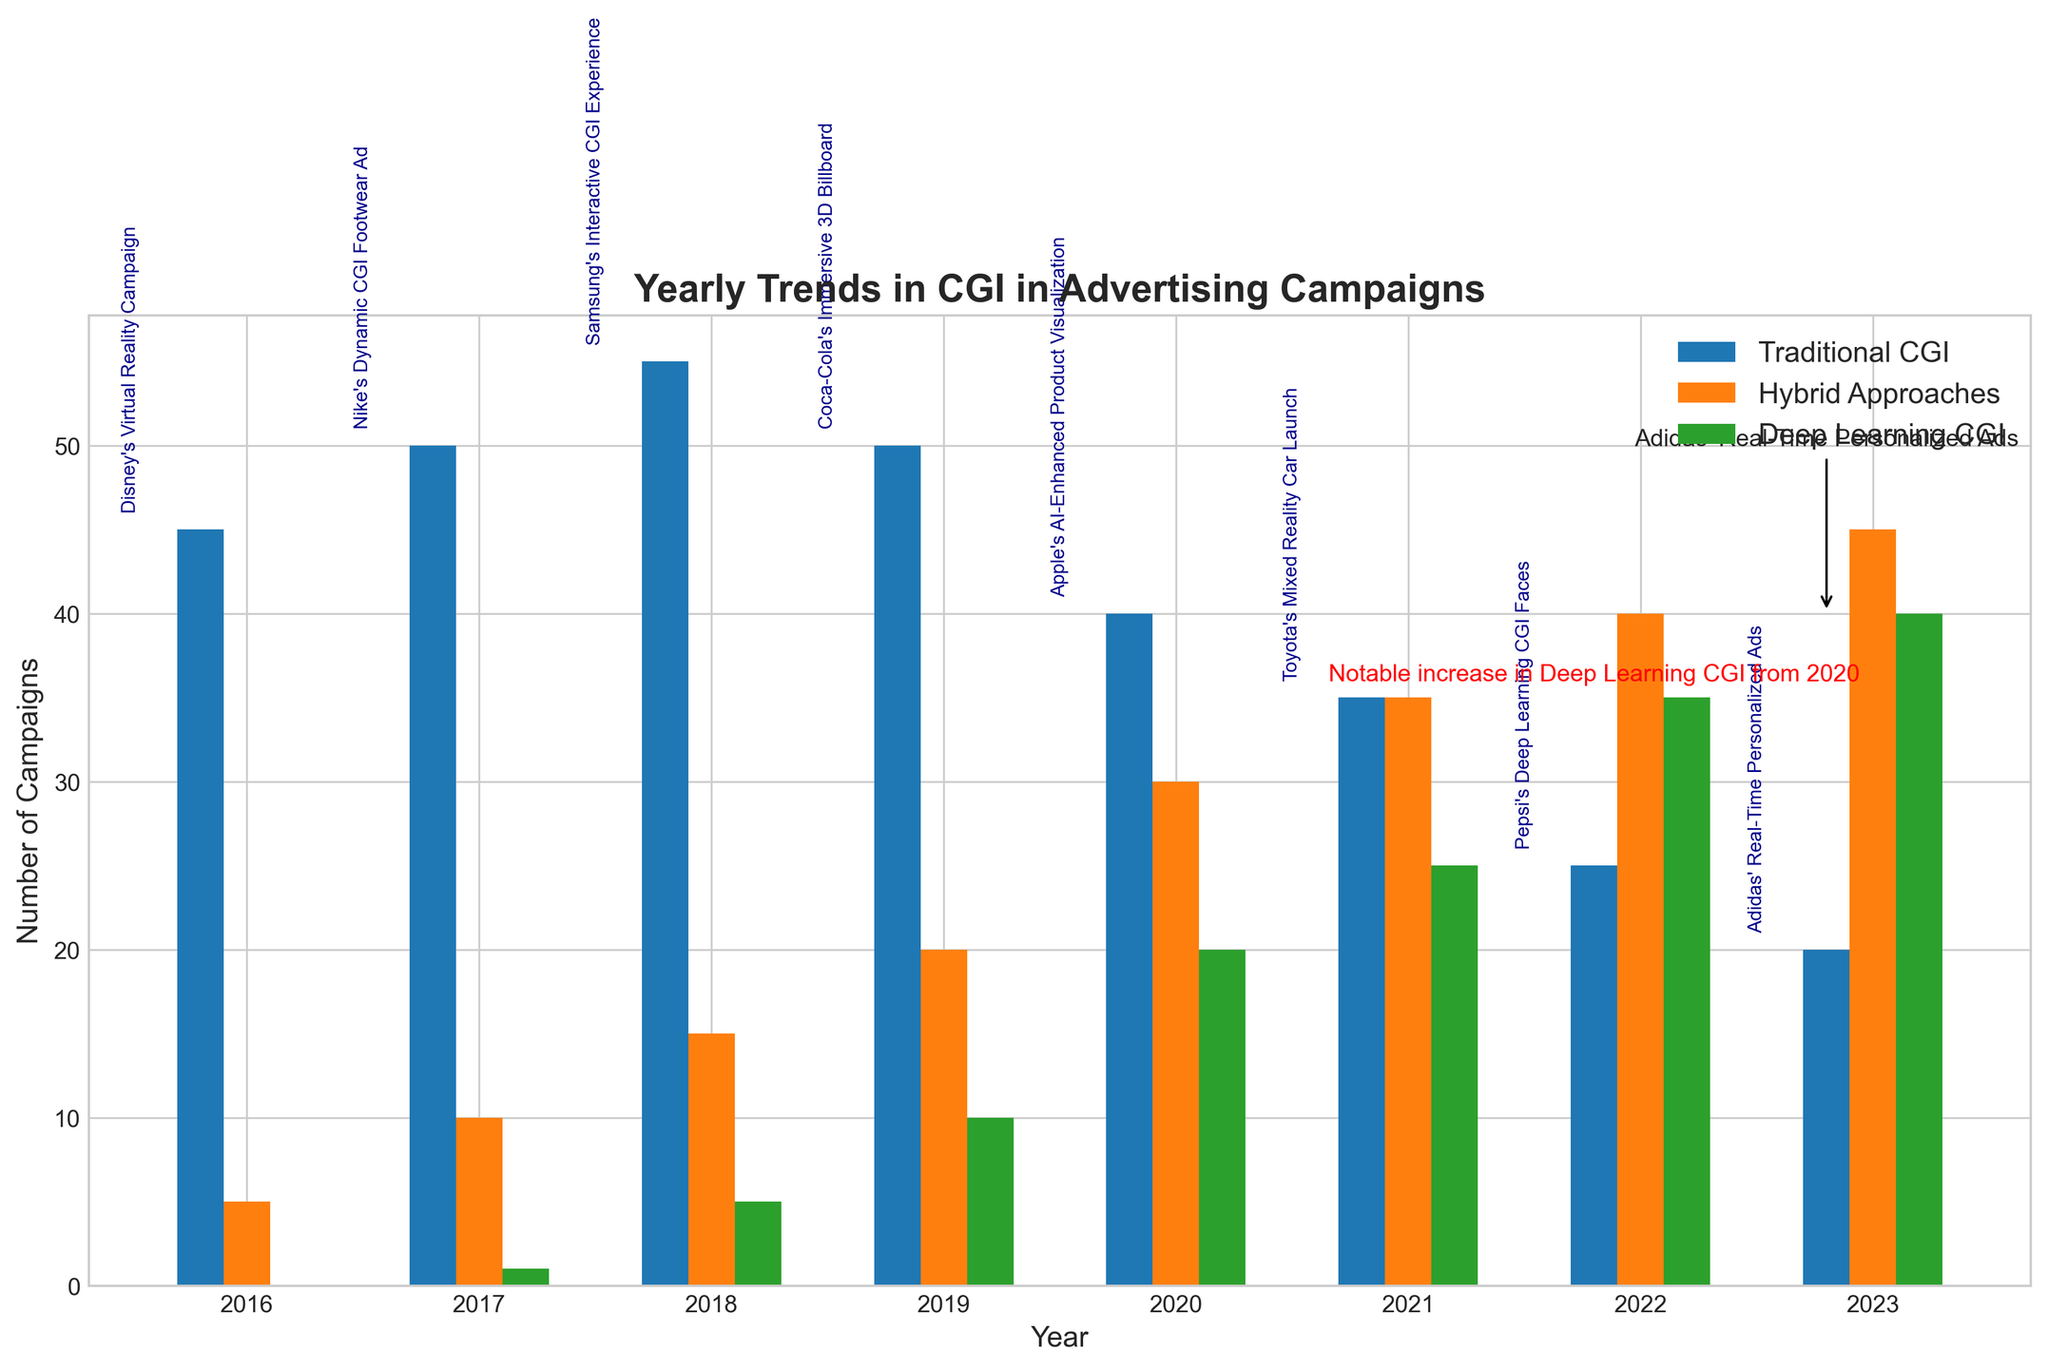what is the total number of campaigns for Traditional CGI in 2016 and 2017? add the number of campaigns for Traditional CGI in 2016 and 2017 from the figure's bars: 45 (2016) + 50 (2017)
Answer: 95 which year shows the highest number of campaigns using Hybrid Approaches? compare the bar heights for Hybrid Approaches across all years and find that 2023 has the highest bar
Answer: 2023 what is the difference in the number of campaigns using Deep Learning CGI between 2022 and 2023? subtract the number of campaigns for Deep Learning CGI in 2022 from the number of campaigns in 2023: 40 (2023) - 35 (2022)
Answer: 5 what is the average number of campaigns using Deep Learning CGI per year from 2020 to 2023? sum the number of campaigns for Deep Learning CGI from 2020 to 2023 and divide by the number of years: (20 + 25 + 35 + 40) / 4 = 120 / 4
Answer: 30 which case study is mentioned for the year with the peak number of Traditional CGI campaigns? find the year with the peak number of Traditional CGI campaigns, which is 2018 with 55 campaigns, and note the corresponding case study: "Samsung's Interactive CGI Experience"
Answer: Samsung's Interactive CGI Experience how many years show more than 30 campaigns using Hybrid Approaches? count the years from the figure where the number of Hybrid Approaches campaigns exceeds 30: 2020, 2021, 2022, and 2023
Answer: 4 which campaign stands out for significantly increasing Deep Learning CGI use? refer to the annotation text on the plot indicating "Notable increase in Deep Learning CGI from 2020" and the specific campaign pointed by the arrow: "Adidas' Real-Time Personalized Ads"
Answer: Adidas' Real-Time Personalized Ads in which year did Deep Learning CGI first appear in advertising campaigns? identify the first year with a non-zero bar for Deep Learning CGI, which is 2017 with 1 campaign
Answer: 2017 compare the number of campaigns using Traditional CGI and Hybrid Approaches in 2021. Which was more prevalent? compare the bar heights for Traditional CGI (35) and Hybrid Approaches (35) in 2021 and find they are equal
Answer: both are equal 